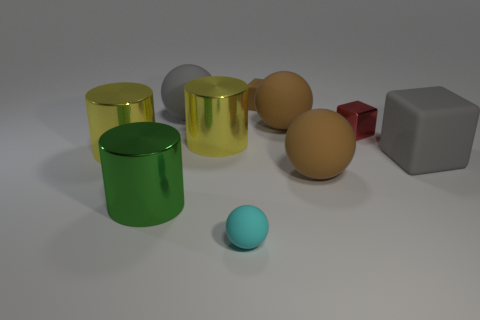There is a small thing that is made of the same material as the green cylinder; what is its shape?
Provide a short and direct response. Cube. Are there any other things that are the same color as the big block?
Your answer should be very brief. Yes. What number of cyan things are there?
Your answer should be very brief. 1. There is a gray thing right of the brown matte object that is behind the gray ball; what is it made of?
Give a very brief answer. Rubber. There is a small matte object that is in front of the large yellow cylinder that is left of the gray matte thing to the left of the tiny matte ball; what is its color?
Keep it short and to the point. Cyan. Do the metallic block and the tiny rubber cube have the same color?
Ensure brevity in your answer.  No. How many cyan spheres have the same size as the brown block?
Provide a succinct answer. 1. Is the number of big brown things that are on the left side of the large cube greater than the number of small brown things that are behind the big green cylinder?
Offer a very short reply. Yes. There is a tiny block that is behind the big gray thing to the left of the small cyan sphere; what is its color?
Keep it short and to the point. Brown. Are the red thing and the cyan sphere made of the same material?
Provide a short and direct response. No. 